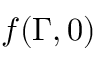<formula> <loc_0><loc_0><loc_500><loc_500>f ( \Gamma , 0 )</formula> 